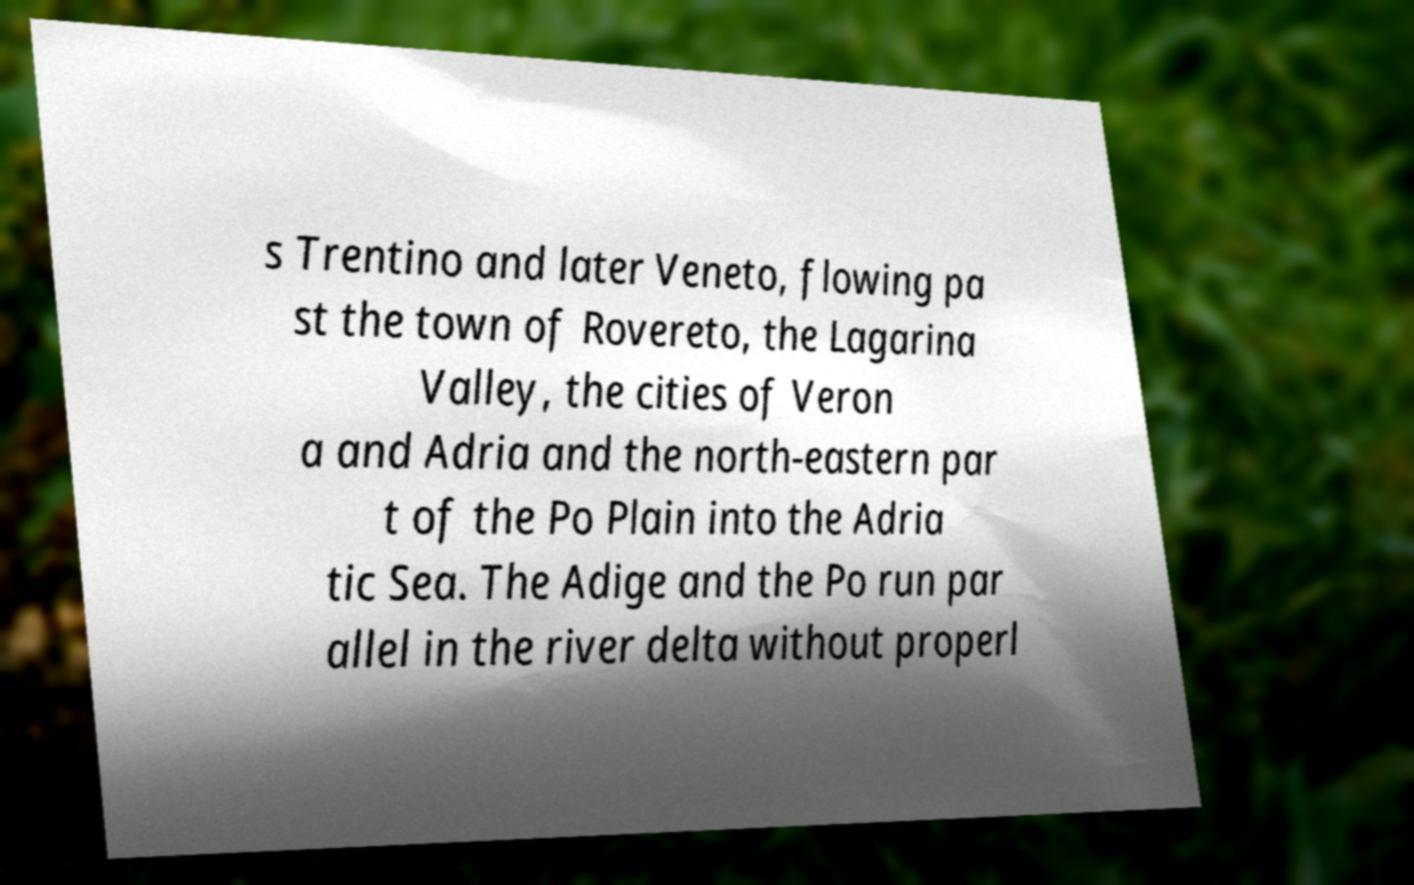What messages or text are displayed in this image? I need them in a readable, typed format. s Trentino and later Veneto, flowing pa st the town of Rovereto, the Lagarina Valley, the cities of Veron a and Adria and the north-eastern par t of the Po Plain into the Adria tic Sea. The Adige and the Po run par allel in the river delta without properl 